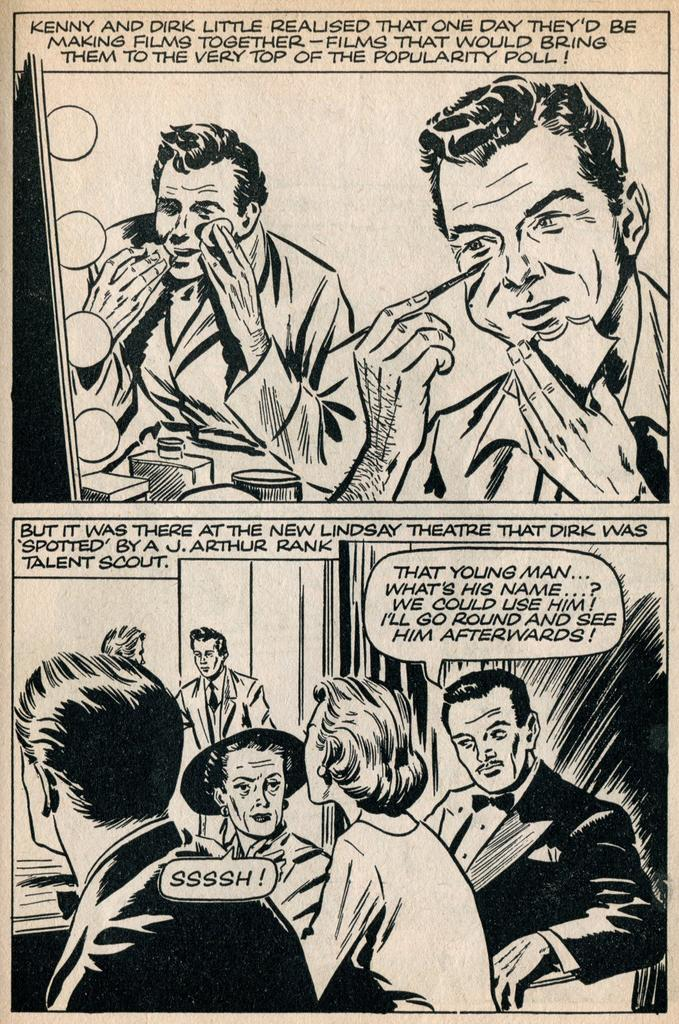<image>
Present a compact description of the photo's key features. In this comic book a man is wondering what another person's name is. 